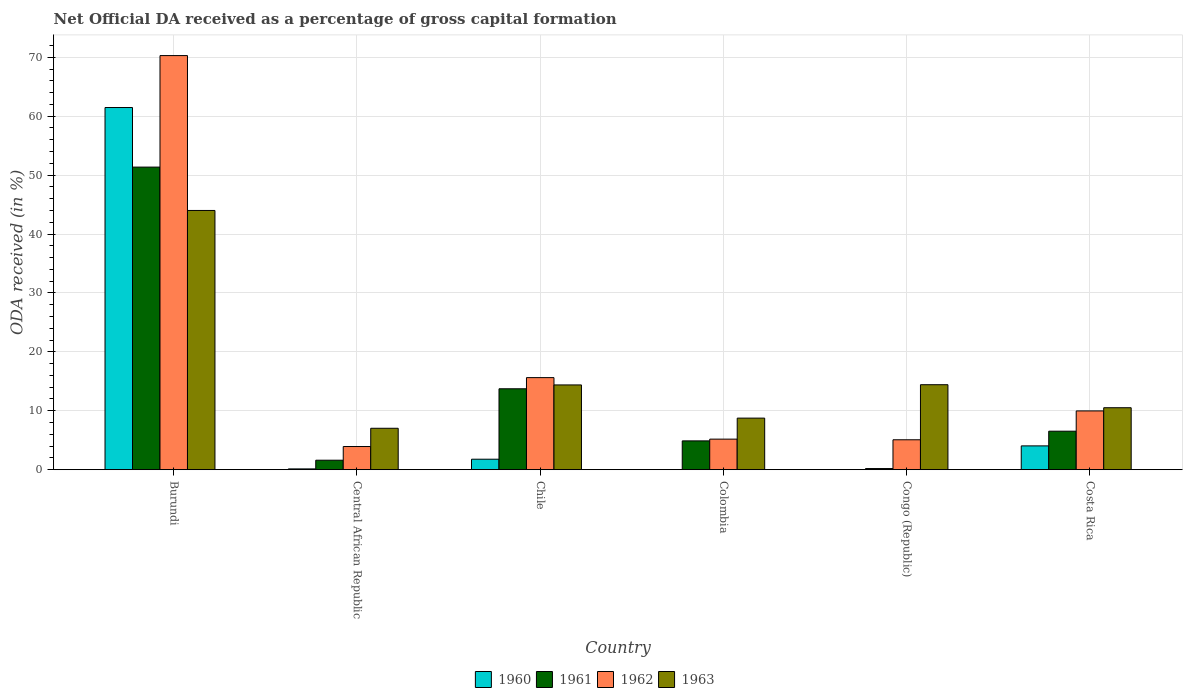How many groups of bars are there?
Provide a short and direct response. 6. Are the number of bars on each tick of the X-axis equal?
Give a very brief answer. No. How many bars are there on the 3rd tick from the right?
Your answer should be compact. 3. What is the label of the 2nd group of bars from the left?
Your answer should be very brief. Central African Republic. In how many cases, is the number of bars for a given country not equal to the number of legend labels?
Your response must be concise. 1. Across all countries, what is the maximum net ODA received in 1962?
Provide a succinct answer. 70.29. Across all countries, what is the minimum net ODA received in 1961?
Give a very brief answer. 0.19. In which country was the net ODA received in 1961 maximum?
Provide a short and direct response. Burundi. What is the total net ODA received in 1961 in the graph?
Provide a succinct answer. 78.32. What is the difference between the net ODA received in 1963 in Central African Republic and that in Congo (Republic)?
Your answer should be very brief. -7.39. What is the difference between the net ODA received in 1961 in Chile and the net ODA received in 1960 in Colombia?
Give a very brief answer. 13.73. What is the average net ODA received in 1960 per country?
Provide a succinct answer. 11.24. What is the difference between the net ODA received of/in 1961 and net ODA received of/in 1963 in Central African Republic?
Provide a short and direct response. -5.42. What is the ratio of the net ODA received in 1961 in Chile to that in Colombia?
Provide a succinct answer. 2.81. Is the net ODA received in 1960 in Burundi less than that in Chile?
Your response must be concise. No. What is the difference between the highest and the second highest net ODA received in 1962?
Keep it short and to the point. -60.31. What is the difference between the highest and the lowest net ODA received in 1963?
Keep it short and to the point. 36.97. In how many countries, is the net ODA received in 1960 greater than the average net ODA received in 1960 taken over all countries?
Make the answer very short. 1. Is the sum of the net ODA received in 1962 in Colombia and Congo (Republic) greater than the maximum net ODA received in 1960 across all countries?
Offer a very short reply. No. Is it the case that in every country, the sum of the net ODA received in 1960 and net ODA received in 1961 is greater than the sum of net ODA received in 1962 and net ODA received in 1963?
Your answer should be compact. No. Is it the case that in every country, the sum of the net ODA received in 1961 and net ODA received in 1963 is greater than the net ODA received in 1962?
Keep it short and to the point. Yes. How many bars are there?
Offer a very short reply. 23. Are all the bars in the graph horizontal?
Provide a succinct answer. No. How many countries are there in the graph?
Keep it short and to the point. 6. What is the difference between two consecutive major ticks on the Y-axis?
Provide a short and direct response. 10. Does the graph contain grids?
Make the answer very short. Yes. Where does the legend appear in the graph?
Ensure brevity in your answer.  Bottom center. What is the title of the graph?
Make the answer very short. Net Official DA received as a percentage of gross capital formation. What is the label or title of the X-axis?
Your answer should be very brief. Country. What is the label or title of the Y-axis?
Provide a succinct answer. ODA received (in %). What is the ODA received (in %) in 1960 in Burundi?
Give a very brief answer. 61.47. What is the ODA received (in %) of 1961 in Burundi?
Provide a succinct answer. 51.36. What is the ODA received (in %) in 1962 in Burundi?
Ensure brevity in your answer.  70.29. What is the ODA received (in %) of 1963 in Burundi?
Offer a terse response. 44. What is the ODA received (in %) in 1960 in Central African Republic?
Your answer should be very brief. 0.14. What is the ODA received (in %) in 1961 in Central African Republic?
Make the answer very short. 1.61. What is the ODA received (in %) in 1962 in Central African Republic?
Provide a succinct answer. 3.93. What is the ODA received (in %) in 1963 in Central African Republic?
Your answer should be very brief. 7.03. What is the ODA received (in %) in 1960 in Chile?
Keep it short and to the point. 1.78. What is the ODA received (in %) in 1961 in Chile?
Ensure brevity in your answer.  13.73. What is the ODA received (in %) in 1962 in Chile?
Your answer should be very brief. 15.63. What is the ODA received (in %) of 1963 in Chile?
Ensure brevity in your answer.  14.39. What is the ODA received (in %) in 1961 in Colombia?
Make the answer very short. 4.89. What is the ODA received (in %) of 1962 in Colombia?
Your answer should be very brief. 5.19. What is the ODA received (in %) in 1963 in Colombia?
Keep it short and to the point. 8.75. What is the ODA received (in %) in 1960 in Congo (Republic)?
Give a very brief answer. 0.03. What is the ODA received (in %) in 1961 in Congo (Republic)?
Ensure brevity in your answer.  0.19. What is the ODA received (in %) in 1962 in Congo (Republic)?
Make the answer very short. 5.08. What is the ODA received (in %) of 1963 in Congo (Republic)?
Make the answer very short. 14.43. What is the ODA received (in %) in 1960 in Costa Rica?
Give a very brief answer. 4.04. What is the ODA received (in %) in 1961 in Costa Rica?
Your response must be concise. 6.54. What is the ODA received (in %) in 1962 in Costa Rica?
Ensure brevity in your answer.  9.98. What is the ODA received (in %) of 1963 in Costa Rica?
Give a very brief answer. 10.52. Across all countries, what is the maximum ODA received (in %) in 1960?
Your response must be concise. 61.47. Across all countries, what is the maximum ODA received (in %) in 1961?
Your answer should be very brief. 51.36. Across all countries, what is the maximum ODA received (in %) of 1962?
Provide a short and direct response. 70.29. Across all countries, what is the maximum ODA received (in %) of 1963?
Make the answer very short. 44. Across all countries, what is the minimum ODA received (in %) in 1961?
Provide a short and direct response. 0.19. Across all countries, what is the minimum ODA received (in %) of 1962?
Make the answer very short. 3.93. Across all countries, what is the minimum ODA received (in %) of 1963?
Provide a succinct answer. 7.03. What is the total ODA received (in %) in 1960 in the graph?
Your response must be concise. 67.46. What is the total ODA received (in %) in 1961 in the graph?
Make the answer very short. 78.32. What is the total ODA received (in %) in 1962 in the graph?
Make the answer very short. 110.09. What is the total ODA received (in %) of 1963 in the graph?
Offer a terse response. 99.12. What is the difference between the ODA received (in %) of 1960 in Burundi and that in Central African Republic?
Provide a short and direct response. 61.33. What is the difference between the ODA received (in %) of 1961 in Burundi and that in Central African Republic?
Offer a terse response. 49.75. What is the difference between the ODA received (in %) of 1962 in Burundi and that in Central African Republic?
Your response must be concise. 66.35. What is the difference between the ODA received (in %) of 1963 in Burundi and that in Central African Republic?
Your response must be concise. 36.97. What is the difference between the ODA received (in %) of 1960 in Burundi and that in Chile?
Ensure brevity in your answer.  59.69. What is the difference between the ODA received (in %) in 1961 in Burundi and that in Chile?
Your answer should be compact. 37.62. What is the difference between the ODA received (in %) of 1962 in Burundi and that in Chile?
Your answer should be compact. 54.66. What is the difference between the ODA received (in %) in 1963 in Burundi and that in Chile?
Ensure brevity in your answer.  29.61. What is the difference between the ODA received (in %) of 1961 in Burundi and that in Colombia?
Provide a short and direct response. 46.47. What is the difference between the ODA received (in %) in 1962 in Burundi and that in Colombia?
Provide a succinct answer. 65.1. What is the difference between the ODA received (in %) in 1963 in Burundi and that in Colombia?
Give a very brief answer. 35.25. What is the difference between the ODA received (in %) in 1960 in Burundi and that in Congo (Republic)?
Give a very brief answer. 61.44. What is the difference between the ODA received (in %) of 1961 in Burundi and that in Congo (Republic)?
Offer a terse response. 51.16. What is the difference between the ODA received (in %) in 1962 in Burundi and that in Congo (Republic)?
Offer a very short reply. 65.21. What is the difference between the ODA received (in %) of 1963 in Burundi and that in Congo (Republic)?
Provide a succinct answer. 29.57. What is the difference between the ODA received (in %) in 1960 in Burundi and that in Costa Rica?
Give a very brief answer. 57.43. What is the difference between the ODA received (in %) of 1961 in Burundi and that in Costa Rica?
Your response must be concise. 44.82. What is the difference between the ODA received (in %) of 1962 in Burundi and that in Costa Rica?
Offer a terse response. 60.31. What is the difference between the ODA received (in %) in 1963 in Burundi and that in Costa Rica?
Your response must be concise. 33.48. What is the difference between the ODA received (in %) in 1960 in Central African Republic and that in Chile?
Your answer should be very brief. -1.64. What is the difference between the ODA received (in %) in 1961 in Central African Republic and that in Chile?
Offer a very short reply. -12.12. What is the difference between the ODA received (in %) of 1962 in Central African Republic and that in Chile?
Offer a terse response. -11.7. What is the difference between the ODA received (in %) of 1963 in Central African Republic and that in Chile?
Offer a very short reply. -7.36. What is the difference between the ODA received (in %) in 1961 in Central African Republic and that in Colombia?
Keep it short and to the point. -3.28. What is the difference between the ODA received (in %) in 1962 in Central African Republic and that in Colombia?
Offer a very short reply. -1.25. What is the difference between the ODA received (in %) of 1963 in Central African Republic and that in Colombia?
Your answer should be very brief. -1.72. What is the difference between the ODA received (in %) of 1960 in Central African Republic and that in Congo (Republic)?
Make the answer very short. 0.11. What is the difference between the ODA received (in %) of 1961 in Central African Republic and that in Congo (Republic)?
Keep it short and to the point. 1.42. What is the difference between the ODA received (in %) of 1962 in Central African Republic and that in Congo (Republic)?
Offer a terse response. -1.15. What is the difference between the ODA received (in %) in 1963 in Central African Republic and that in Congo (Republic)?
Offer a very short reply. -7.39. What is the difference between the ODA received (in %) of 1960 in Central African Republic and that in Costa Rica?
Your answer should be very brief. -3.91. What is the difference between the ODA received (in %) of 1961 in Central African Republic and that in Costa Rica?
Keep it short and to the point. -4.93. What is the difference between the ODA received (in %) of 1962 in Central African Republic and that in Costa Rica?
Your answer should be very brief. -6.04. What is the difference between the ODA received (in %) in 1963 in Central African Republic and that in Costa Rica?
Your answer should be very brief. -3.49. What is the difference between the ODA received (in %) in 1961 in Chile and that in Colombia?
Provide a short and direct response. 8.84. What is the difference between the ODA received (in %) in 1962 in Chile and that in Colombia?
Your answer should be very brief. 10.44. What is the difference between the ODA received (in %) in 1963 in Chile and that in Colombia?
Provide a succinct answer. 5.63. What is the difference between the ODA received (in %) of 1960 in Chile and that in Congo (Republic)?
Your answer should be compact. 1.75. What is the difference between the ODA received (in %) in 1961 in Chile and that in Congo (Republic)?
Provide a short and direct response. 13.54. What is the difference between the ODA received (in %) of 1962 in Chile and that in Congo (Republic)?
Give a very brief answer. 10.55. What is the difference between the ODA received (in %) of 1963 in Chile and that in Congo (Republic)?
Ensure brevity in your answer.  -0.04. What is the difference between the ODA received (in %) in 1960 in Chile and that in Costa Rica?
Make the answer very short. -2.26. What is the difference between the ODA received (in %) in 1961 in Chile and that in Costa Rica?
Ensure brevity in your answer.  7.2. What is the difference between the ODA received (in %) of 1962 in Chile and that in Costa Rica?
Make the answer very short. 5.65. What is the difference between the ODA received (in %) of 1963 in Chile and that in Costa Rica?
Offer a very short reply. 3.87. What is the difference between the ODA received (in %) of 1961 in Colombia and that in Congo (Republic)?
Provide a short and direct response. 4.7. What is the difference between the ODA received (in %) in 1962 in Colombia and that in Congo (Republic)?
Keep it short and to the point. 0.11. What is the difference between the ODA received (in %) of 1963 in Colombia and that in Congo (Republic)?
Your answer should be compact. -5.67. What is the difference between the ODA received (in %) in 1961 in Colombia and that in Costa Rica?
Make the answer very short. -1.65. What is the difference between the ODA received (in %) of 1962 in Colombia and that in Costa Rica?
Make the answer very short. -4.79. What is the difference between the ODA received (in %) of 1963 in Colombia and that in Costa Rica?
Ensure brevity in your answer.  -1.76. What is the difference between the ODA received (in %) of 1960 in Congo (Republic) and that in Costa Rica?
Ensure brevity in your answer.  -4.01. What is the difference between the ODA received (in %) in 1961 in Congo (Republic) and that in Costa Rica?
Offer a terse response. -6.34. What is the difference between the ODA received (in %) in 1962 in Congo (Republic) and that in Costa Rica?
Offer a terse response. -4.9. What is the difference between the ODA received (in %) of 1963 in Congo (Republic) and that in Costa Rica?
Provide a short and direct response. 3.91. What is the difference between the ODA received (in %) of 1960 in Burundi and the ODA received (in %) of 1961 in Central African Republic?
Give a very brief answer. 59.86. What is the difference between the ODA received (in %) in 1960 in Burundi and the ODA received (in %) in 1962 in Central African Republic?
Offer a very short reply. 57.54. What is the difference between the ODA received (in %) of 1960 in Burundi and the ODA received (in %) of 1963 in Central African Republic?
Ensure brevity in your answer.  54.44. What is the difference between the ODA received (in %) in 1961 in Burundi and the ODA received (in %) in 1962 in Central African Republic?
Offer a terse response. 47.42. What is the difference between the ODA received (in %) in 1961 in Burundi and the ODA received (in %) in 1963 in Central African Republic?
Provide a succinct answer. 44.33. What is the difference between the ODA received (in %) of 1962 in Burundi and the ODA received (in %) of 1963 in Central African Republic?
Ensure brevity in your answer.  63.25. What is the difference between the ODA received (in %) in 1960 in Burundi and the ODA received (in %) in 1961 in Chile?
Your answer should be very brief. 47.73. What is the difference between the ODA received (in %) in 1960 in Burundi and the ODA received (in %) in 1962 in Chile?
Offer a terse response. 45.84. What is the difference between the ODA received (in %) in 1960 in Burundi and the ODA received (in %) in 1963 in Chile?
Provide a short and direct response. 47.08. What is the difference between the ODA received (in %) in 1961 in Burundi and the ODA received (in %) in 1962 in Chile?
Keep it short and to the point. 35.73. What is the difference between the ODA received (in %) in 1961 in Burundi and the ODA received (in %) in 1963 in Chile?
Make the answer very short. 36.97. What is the difference between the ODA received (in %) in 1962 in Burundi and the ODA received (in %) in 1963 in Chile?
Provide a succinct answer. 55.9. What is the difference between the ODA received (in %) of 1960 in Burundi and the ODA received (in %) of 1961 in Colombia?
Give a very brief answer. 56.58. What is the difference between the ODA received (in %) in 1960 in Burundi and the ODA received (in %) in 1962 in Colombia?
Offer a very short reply. 56.28. What is the difference between the ODA received (in %) in 1960 in Burundi and the ODA received (in %) in 1963 in Colombia?
Offer a terse response. 52.72. What is the difference between the ODA received (in %) in 1961 in Burundi and the ODA received (in %) in 1962 in Colombia?
Provide a succinct answer. 46.17. What is the difference between the ODA received (in %) in 1961 in Burundi and the ODA received (in %) in 1963 in Colombia?
Offer a terse response. 42.6. What is the difference between the ODA received (in %) in 1962 in Burundi and the ODA received (in %) in 1963 in Colombia?
Your answer should be very brief. 61.53. What is the difference between the ODA received (in %) of 1960 in Burundi and the ODA received (in %) of 1961 in Congo (Republic)?
Make the answer very short. 61.28. What is the difference between the ODA received (in %) of 1960 in Burundi and the ODA received (in %) of 1962 in Congo (Republic)?
Ensure brevity in your answer.  56.39. What is the difference between the ODA received (in %) of 1960 in Burundi and the ODA received (in %) of 1963 in Congo (Republic)?
Your answer should be compact. 47.04. What is the difference between the ODA received (in %) of 1961 in Burundi and the ODA received (in %) of 1962 in Congo (Republic)?
Your answer should be very brief. 46.28. What is the difference between the ODA received (in %) of 1961 in Burundi and the ODA received (in %) of 1963 in Congo (Republic)?
Your answer should be very brief. 36.93. What is the difference between the ODA received (in %) in 1962 in Burundi and the ODA received (in %) in 1963 in Congo (Republic)?
Your answer should be compact. 55.86. What is the difference between the ODA received (in %) of 1960 in Burundi and the ODA received (in %) of 1961 in Costa Rica?
Your answer should be compact. 54.93. What is the difference between the ODA received (in %) in 1960 in Burundi and the ODA received (in %) in 1962 in Costa Rica?
Offer a terse response. 51.49. What is the difference between the ODA received (in %) of 1960 in Burundi and the ODA received (in %) of 1963 in Costa Rica?
Give a very brief answer. 50.95. What is the difference between the ODA received (in %) of 1961 in Burundi and the ODA received (in %) of 1962 in Costa Rica?
Provide a succinct answer. 41.38. What is the difference between the ODA received (in %) of 1961 in Burundi and the ODA received (in %) of 1963 in Costa Rica?
Make the answer very short. 40.84. What is the difference between the ODA received (in %) of 1962 in Burundi and the ODA received (in %) of 1963 in Costa Rica?
Keep it short and to the point. 59.77. What is the difference between the ODA received (in %) in 1960 in Central African Republic and the ODA received (in %) in 1961 in Chile?
Offer a terse response. -13.6. What is the difference between the ODA received (in %) in 1960 in Central African Republic and the ODA received (in %) in 1962 in Chile?
Ensure brevity in your answer.  -15.49. What is the difference between the ODA received (in %) of 1960 in Central African Republic and the ODA received (in %) of 1963 in Chile?
Your response must be concise. -14.25. What is the difference between the ODA received (in %) of 1961 in Central African Republic and the ODA received (in %) of 1962 in Chile?
Keep it short and to the point. -14.02. What is the difference between the ODA received (in %) in 1961 in Central African Republic and the ODA received (in %) in 1963 in Chile?
Make the answer very short. -12.78. What is the difference between the ODA received (in %) in 1962 in Central African Republic and the ODA received (in %) in 1963 in Chile?
Keep it short and to the point. -10.45. What is the difference between the ODA received (in %) in 1960 in Central African Republic and the ODA received (in %) in 1961 in Colombia?
Offer a terse response. -4.75. What is the difference between the ODA received (in %) of 1960 in Central African Republic and the ODA received (in %) of 1962 in Colombia?
Make the answer very short. -5.05. What is the difference between the ODA received (in %) in 1960 in Central African Republic and the ODA received (in %) in 1963 in Colombia?
Offer a very short reply. -8.62. What is the difference between the ODA received (in %) of 1961 in Central African Republic and the ODA received (in %) of 1962 in Colombia?
Your response must be concise. -3.58. What is the difference between the ODA received (in %) of 1961 in Central African Republic and the ODA received (in %) of 1963 in Colombia?
Offer a very short reply. -7.14. What is the difference between the ODA received (in %) of 1962 in Central African Republic and the ODA received (in %) of 1963 in Colombia?
Offer a terse response. -4.82. What is the difference between the ODA received (in %) in 1960 in Central African Republic and the ODA received (in %) in 1961 in Congo (Republic)?
Ensure brevity in your answer.  -0.06. What is the difference between the ODA received (in %) of 1960 in Central African Republic and the ODA received (in %) of 1962 in Congo (Republic)?
Your answer should be compact. -4.94. What is the difference between the ODA received (in %) in 1960 in Central African Republic and the ODA received (in %) in 1963 in Congo (Republic)?
Make the answer very short. -14.29. What is the difference between the ODA received (in %) of 1961 in Central African Republic and the ODA received (in %) of 1962 in Congo (Republic)?
Offer a very short reply. -3.47. What is the difference between the ODA received (in %) of 1961 in Central African Republic and the ODA received (in %) of 1963 in Congo (Republic)?
Make the answer very short. -12.82. What is the difference between the ODA received (in %) of 1962 in Central African Republic and the ODA received (in %) of 1963 in Congo (Republic)?
Keep it short and to the point. -10.49. What is the difference between the ODA received (in %) of 1960 in Central African Republic and the ODA received (in %) of 1961 in Costa Rica?
Your answer should be very brief. -6.4. What is the difference between the ODA received (in %) of 1960 in Central African Republic and the ODA received (in %) of 1962 in Costa Rica?
Offer a terse response. -9.84. What is the difference between the ODA received (in %) of 1960 in Central African Republic and the ODA received (in %) of 1963 in Costa Rica?
Give a very brief answer. -10.38. What is the difference between the ODA received (in %) in 1961 in Central African Republic and the ODA received (in %) in 1962 in Costa Rica?
Your response must be concise. -8.37. What is the difference between the ODA received (in %) in 1961 in Central African Republic and the ODA received (in %) in 1963 in Costa Rica?
Make the answer very short. -8.91. What is the difference between the ODA received (in %) in 1962 in Central African Republic and the ODA received (in %) in 1963 in Costa Rica?
Provide a succinct answer. -6.58. What is the difference between the ODA received (in %) of 1960 in Chile and the ODA received (in %) of 1961 in Colombia?
Your response must be concise. -3.11. What is the difference between the ODA received (in %) of 1960 in Chile and the ODA received (in %) of 1962 in Colombia?
Offer a very short reply. -3.41. What is the difference between the ODA received (in %) in 1960 in Chile and the ODA received (in %) in 1963 in Colombia?
Make the answer very short. -6.97. What is the difference between the ODA received (in %) in 1961 in Chile and the ODA received (in %) in 1962 in Colombia?
Ensure brevity in your answer.  8.55. What is the difference between the ODA received (in %) in 1961 in Chile and the ODA received (in %) in 1963 in Colombia?
Offer a terse response. 4.98. What is the difference between the ODA received (in %) in 1962 in Chile and the ODA received (in %) in 1963 in Colombia?
Provide a short and direct response. 6.88. What is the difference between the ODA received (in %) of 1960 in Chile and the ODA received (in %) of 1961 in Congo (Republic)?
Your response must be concise. 1.59. What is the difference between the ODA received (in %) in 1960 in Chile and the ODA received (in %) in 1962 in Congo (Republic)?
Provide a short and direct response. -3.3. What is the difference between the ODA received (in %) in 1960 in Chile and the ODA received (in %) in 1963 in Congo (Republic)?
Ensure brevity in your answer.  -12.65. What is the difference between the ODA received (in %) in 1961 in Chile and the ODA received (in %) in 1962 in Congo (Republic)?
Give a very brief answer. 8.66. What is the difference between the ODA received (in %) of 1961 in Chile and the ODA received (in %) of 1963 in Congo (Republic)?
Offer a very short reply. -0.69. What is the difference between the ODA received (in %) in 1962 in Chile and the ODA received (in %) in 1963 in Congo (Republic)?
Ensure brevity in your answer.  1.2. What is the difference between the ODA received (in %) of 1960 in Chile and the ODA received (in %) of 1961 in Costa Rica?
Provide a short and direct response. -4.76. What is the difference between the ODA received (in %) of 1960 in Chile and the ODA received (in %) of 1962 in Costa Rica?
Your answer should be compact. -8.2. What is the difference between the ODA received (in %) in 1960 in Chile and the ODA received (in %) in 1963 in Costa Rica?
Ensure brevity in your answer.  -8.74. What is the difference between the ODA received (in %) in 1961 in Chile and the ODA received (in %) in 1962 in Costa Rica?
Make the answer very short. 3.76. What is the difference between the ODA received (in %) of 1961 in Chile and the ODA received (in %) of 1963 in Costa Rica?
Your response must be concise. 3.22. What is the difference between the ODA received (in %) of 1962 in Chile and the ODA received (in %) of 1963 in Costa Rica?
Give a very brief answer. 5.11. What is the difference between the ODA received (in %) of 1961 in Colombia and the ODA received (in %) of 1962 in Congo (Republic)?
Provide a succinct answer. -0.19. What is the difference between the ODA received (in %) of 1961 in Colombia and the ODA received (in %) of 1963 in Congo (Republic)?
Provide a succinct answer. -9.54. What is the difference between the ODA received (in %) of 1962 in Colombia and the ODA received (in %) of 1963 in Congo (Republic)?
Your answer should be compact. -9.24. What is the difference between the ODA received (in %) of 1961 in Colombia and the ODA received (in %) of 1962 in Costa Rica?
Make the answer very short. -5.09. What is the difference between the ODA received (in %) in 1961 in Colombia and the ODA received (in %) in 1963 in Costa Rica?
Offer a very short reply. -5.63. What is the difference between the ODA received (in %) of 1962 in Colombia and the ODA received (in %) of 1963 in Costa Rica?
Ensure brevity in your answer.  -5.33. What is the difference between the ODA received (in %) in 1960 in Congo (Republic) and the ODA received (in %) in 1961 in Costa Rica?
Your answer should be very brief. -6.51. What is the difference between the ODA received (in %) in 1960 in Congo (Republic) and the ODA received (in %) in 1962 in Costa Rica?
Provide a succinct answer. -9.95. What is the difference between the ODA received (in %) of 1960 in Congo (Republic) and the ODA received (in %) of 1963 in Costa Rica?
Offer a terse response. -10.49. What is the difference between the ODA received (in %) of 1961 in Congo (Republic) and the ODA received (in %) of 1962 in Costa Rica?
Ensure brevity in your answer.  -9.78. What is the difference between the ODA received (in %) of 1961 in Congo (Republic) and the ODA received (in %) of 1963 in Costa Rica?
Provide a succinct answer. -10.32. What is the difference between the ODA received (in %) of 1962 in Congo (Republic) and the ODA received (in %) of 1963 in Costa Rica?
Provide a succinct answer. -5.44. What is the average ODA received (in %) of 1960 per country?
Keep it short and to the point. 11.24. What is the average ODA received (in %) of 1961 per country?
Provide a succinct answer. 13.05. What is the average ODA received (in %) in 1962 per country?
Provide a short and direct response. 18.35. What is the average ODA received (in %) in 1963 per country?
Your answer should be very brief. 16.52. What is the difference between the ODA received (in %) in 1960 and ODA received (in %) in 1961 in Burundi?
Your answer should be compact. 10.11. What is the difference between the ODA received (in %) in 1960 and ODA received (in %) in 1962 in Burundi?
Keep it short and to the point. -8.82. What is the difference between the ODA received (in %) in 1960 and ODA received (in %) in 1963 in Burundi?
Your response must be concise. 17.47. What is the difference between the ODA received (in %) of 1961 and ODA received (in %) of 1962 in Burundi?
Offer a terse response. -18.93. What is the difference between the ODA received (in %) of 1961 and ODA received (in %) of 1963 in Burundi?
Your response must be concise. 7.36. What is the difference between the ODA received (in %) in 1962 and ODA received (in %) in 1963 in Burundi?
Keep it short and to the point. 26.29. What is the difference between the ODA received (in %) of 1960 and ODA received (in %) of 1961 in Central African Republic?
Make the answer very short. -1.47. What is the difference between the ODA received (in %) in 1960 and ODA received (in %) in 1962 in Central African Republic?
Your answer should be very brief. -3.8. What is the difference between the ODA received (in %) of 1960 and ODA received (in %) of 1963 in Central African Republic?
Offer a very short reply. -6.89. What is the difference between the ODA received (in %) of 1961 and ODA received (in %) of 1962 in Central African Republic?
Offer a terse response. -2.32. What is the difference between the ODA received (in %) of 1961 and ODA received (in %) of 1963 in Central African Republic?
Make the answer very short. -5.42. What is the difference between the ODA received (in %) of 1962 and ODA received (in %) of 1963 in Central African Republic?
Provide a succinct answer. -3.1. What is the difference between the ODA received (in %) in 1960 and ODA received (in %) in 1961 in Chile?
Your response must be concise. -11.96. What is the difference between the ODA received (in %) in 1960 and ODA received (in %) in 1962 in Chile?
Ensure brevity in your answer.  -13.85. What is the difference between the ODA received (in %) in 1960 and ODA received (in %) in 1963 in Chile?
Offer a terse response. -12.61. What is the difference between the ODA received (in %) of 1961 and ODA received (in %) of 1962 in Chile?
Give a very brief answer. -1.89. What is the difference between the ODA received (in %) of 1961 and ODA received (in %) of 1963 in Chile?
Ensure brevity in your answer.  -0.65. What is the difference between the ODA received (in %) of 1962 and ODA received (in %) of 1963 in Chile?
Offer a very short reply. 1.24. What is the difference between the ODA received (in %) in 1961 and ODA received (in %) in 1962 in Colombia?
Your answer should be very brief. -0.3. What is the difference between the ODA received (in %) in 1961 and ODA received (in %) in 1963 in Colombia?
Provide a short and direct response. -3.86. What is the difference between the ODA received (in %) of 1962 and ODA received (in %) of 1963 in Colombia?
Your response must be concise. -3.57. What is the difference between the ODA received (in %) of 1960 and ODA received (in %) of 1961 in Congo (Republic)?
Give a very brief answer. -0.17. What is the difference between the ODA received (in %) of 1960 and ODA received (in %) of 1962 in Congo (Republic)?
Provide a short and direct response. -5.05. What is the difference between the ODA received (in %) of 1960 and ODA received (in %) of 1963 in Congo (Republic)?
Your response must be concise. -14.4. What is the difference between the ODA received (in %) in 1961 and ODA received (in %) in 1962 in Congo (Republic)?
Provide a short and direct response. -4.89. What is the difference between the ODA received (in %) of 1961 and ODA received (in %) of 1963 in Congo (Republic)?
Your response must be concise. -14.23. What is the difference between the ODA received (in %) in 1962 and ODA received (in %) in 1963 in Congo (Republic)?
Provide a succinct answer. -9.35. What is the difference between the ODA received (in %) in 1960 and ODA received (in %) in 1961 in Costa Rica?
Your response must be concise. -2.49. What is the difference between the ODA received (in %) of 1960 and ODA received (in %) of 1962 in Costa Rica?
Provide a succinct answer. -5.93. What is the difference between the ODA received (in %) of 1960 and ODA received (in %) of 1963 in Costa Rica?
Give a very brief answer. -6.48. What is the difference between the ODA received (in %) in 1961 and ODA received (in %) in 1962 in Costa Rica?
Ensure brevity in your answer.  -3.44. What is the difference between the ODA received (in %) in 1961 and ODA received (in %) in 1963 in Costa Rica?
Your answer should be very brief. -3.98. What is the difference between the ODA received (in %) of 1962 and ODA received (in %) of 1963 in Costa Rica?
Your answer should be very brief. -0.54. What is the ratio of the ODA received (in %) of 1960 in Burundi to that in Central African Republic?
Offer a terse response. 451.25. What is the ratio of the ODA received (in %) of 1961 in Burundi to that in Central African Republic?
Provide a short and direct response. 31.91. What is the ratio of the ODA received (in %) in 1962 in Burundi to that in Central African Republic?
Offer a terse response. 17.87. What is the ratio of the ODA received (in %) in 1963 in Burundi to that in Central African Republic?
Keep it short and to the point. 6.26. What is the ratio of the ODA received (in %) in 1960 in Burundi to that in Chile?
Your response must be concise. 34.55. What is the ratio of the ODA received (in %) of 1961 in Burundi to that in Chile?
Keep it short and to the point. 3.74. What is the ratio of the ODA received (in %) of 1962 in Burundi to that in Chile?
Give a very brief answer. 4.5. What is the ratio of the ODA received (in %) in 1963 in Burundi to that in Chile?
Offer a very short reply. 3.06. What is the ratio of the ODA received (in %) in 1961 in Burundi to that in Colombia?
Make the answer very short. 10.5. What is the ratio of the ODA received (in %) in 1962 in Burundi to that in Colombia?
Offer a very short reply. 13.55. What is the ratio of the ODA received (in %) of 1963 in Burundi to that in Colombia?
Offer a very short reply. 5.03. What is the ratio of the ODA received (in %) in 1960 in Burundi to that in Congo (Republic)?
Your answer should be very brief. 2153.4. What is the ratio of the ODA received (in %) of 1961 in Burundi to that in Congo (Republic)?
Provide a succinct answer. 265.07. What is the ratio of the ODA received (in %) of 1962 in Burundi to that in Congo (Republic)?
Your answer should be compact. 13.84. What is the ratio of the ODA received (in %) in 1963 in Burundi to that in Congo (Republic)?
Ensure brevity in your answer.  3.05. What is the ratio of the ODA received (in %) of 1960 in Burundi to that in Costa Rica?
Your answer should be very brief. 15.21. What is the ratio of the ODA received (in %) in 1961 in Burundi to that in Costa Rica?
Offer a terse response. 7.86. What is the ratio of the ODA received (in %) in 1962 in Burundi to that in Costa Rica?
Your answer should be compact. 7.04. What is the ratio of the ODA received (in %) of 1963 in Burundi to that in Costa Rica?
Ensure brevity in your answer.  4.18. What is the ratio of the ODA received (in %) of 1960 in Central African Republic to that in Chile?
Provide a short and direct response. 0.08. What is the ratio of the ODA received (in %) in 1961 in Central African Republic to that in Chile?
Keep it short and to the point. 0.12. What is the ratio of the ODA received (in %) of 1962 in Central African Republic to that in Chile?
Give a very brief answer. 0.25. What is the ratio of the ODA received (in %) in 1963 in Central African Republic to that in Chile?
Your answer should be very brief. 0.49. What is the ratio of the ODA received (in %) in 1961 in Central African Republic to that in Colombia?
Offer a terse response. 0.33. What is the ratio of the ODA received (in %) in 1962 in Central African Republic to that in Colombia?
Ensure brevity in your answer.  0.76. What is the ratio of the ODA received (in %) of 1963 in Central African Republic to that in Colombia?
Keep it short and to the point. 0.8. What is the ratio of the ODA received (in %) in 1960 in Central African Republic to that in Congo (Republic)?
Provide a succinct answer. 4.77. What is the ratio of the ODA received (in %) of 1961 in Central African Republic to that in Congo (Republic)?
Provide a short and direct response. 8.31. What is the ratio of the ODA received (in %) in 1962 in Central African Republic to that in Congo (Republic)?
Ensure brevity in your answer.  0.77. What is the ratio of the ODA received (in %) in 1963 in Central African Republic to that in Congo (Republic)?
Offer a terse response. 0.49. What is the ratio of the ODA received (in %) of 1960 in Central African Republic to that in Costa Rica?
Give a very brief answer. 0.03. What is the ratio of the ODA received (in %) of 1961 in Central African Republic to that in Costa Rica?
Provide a short and direct response. 0.25. What is the ratio of the ODA received (in %) in 1962 in Central African Republic to that in Costa Rica?
Offer a terse response. 0.39. What is the ratio of the ODA received (in %) of 1963 in Central African Republic to that in Costa Rica?
Provide a succinct answer. 0.67. What is the ratio of the ODA received (in %) in 1961 in Chile to that in Colombia?
Your response must be concise. 2.81. What is the ratio of the ODA received (in %) of 1962 in Chile to that in Colombia?
Keep it short and to the point. 3.01. What is the ratio of the ODA received (in %) of 1963 in Chile to that in Colombia?
Make the answer very short. 1.64. What is the ratio of the ODA received (in %) of 1960 in Chile to that in Congo (Republic)?
Offer a very short reply. 62.32. What is the ratio of the ODA received (in %) in 1961 in Chile to that in Congo (Republic)?
Your answer should be compact. 70.89. What is the ratio of the ODA received (in %) of 1962 in Chile to that in Congo (Republic)?
Give a very brief answer. 3.08. What is the ratio of the ODA received (in %) in 1960 in Chile to that in Costa Rica?
Your answer should be compact. 0.44. What is the ratio of the ODA received (in %) in 1961 in Chile to that in Costa Rica?
Ensure brevity in your answer.  2.1. What is the ratio of the ODA received (in %) in 1962 in Chile to that in Costa Rica?
Give a very brief answer. 1.57. What is the ratio of the ODA received (in %) in 1963 in Chile to that in Costa Rica?
Offer a terse response. 1.37. What is the ratio of the ODA received (in %) of 1961 in Colombia to that in Congo (Republic)?
Provide a succinct answer. 25.24. What is the ratio of the ODA received (in %) in 1962 in Colombia to that in Congo (Republic)?
Give a very brief answer. 1.02. What is the ratio of the ODA received (in %) in 1963 in Colombia to that in Congo (Republic)?
Your response must be concise. 0.61. What is the ratio of the ODA received (in %) of 1961 in Colombia to that in Costa Rica?
Your answer should be compact. 0.75. What is the ratio of the ODA received (in %) in 1962 in Colombia to that in Costa Rica?
Provide a succinct answer. 0.52. What is the ratio of the ODA received (in %) in 1963 in Colombia to that in Costa Rica?
Offer a very short reply. 0.83. What is the ratio of the ODA received (in %) of 1960 in Congo (Republic) to that in Costa Rica?
Your answer should be very brief. 0.01. What is the ratio of the ODA received (in %) of 1961 in Congo (Republic) to that in Costa Rica?
Make the answer very short. 0.03. What is the ratio of the ODA received (in %) of 1962 in Congo (Republic) to that in Costa Rica?
Your response must be concise. 0.51. What is the ratio of the ODA received (in %) in 1963 in Congo (Republic) to that in Costa Rica?
Your response must be concise. 1.37. What is the difference between the highest and the second highest ODA received (in %) of 1960?
Offer a very short reply. 57.43. What is the difference between the highest and the second highest ODA received (in %) of 1961?
Offer a very short reply. 37.62. What is the difference between the highest and the second highest ODA received (in %) of 1962?
Ensure brevity in your answer.  54.66. What is the difference between the highest and the second highest ODA received (in %) in 1963?
Provide a short and direct response. 29.57. What is the difference between the highest and the lowest ODA received (in %) of 1960?
Your answer should be compact. 61.47. What is the difference between the highest and the lowest ODA received (in %) in 1961?
Offer a terse response. 51.16. What is the difference between the highest and the lowest ODA received (in %) in 1962?
Make the answer very short. 66.35. What is the difference between the highest and the lowest ODA received (in %) of 1963?
Provide a succinct answer. 36.97. 